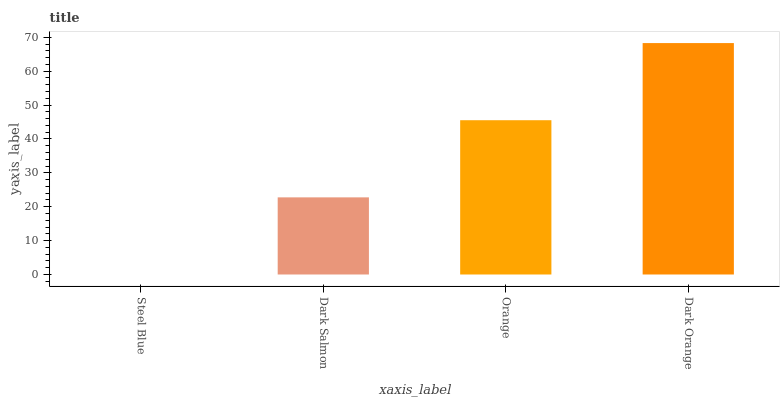Is Steel Blue the minimum?
Answer yes or no. Yes. Is Dark Orange the maximum?
Answer yes or no. Yes. Is Dark Salmon the minimum?
Answer yes or no. No. Is Dark Salmon the maximum?
Answer yes or no. No. Is Dark Salmon greater than Steel Blue?
Answer yes or no. Yes. Is Steel Blue less than Dark Salmon?
Answer yes or no. Yes. Is Steel Blue greater than Dark Salmon?
Answer yes or no. No. Is Dark Salmon less than Steel Blue?
Answer yes or no. No. Is Orange the high median?
Answer yes or no. Yes. Is Dark Salmon the low median?
Answer yes or no. Yes. Is Steel Blue the high median?
Answer yes or no. No. Is Steel Blue the low median?
Answer yes or no. No. 